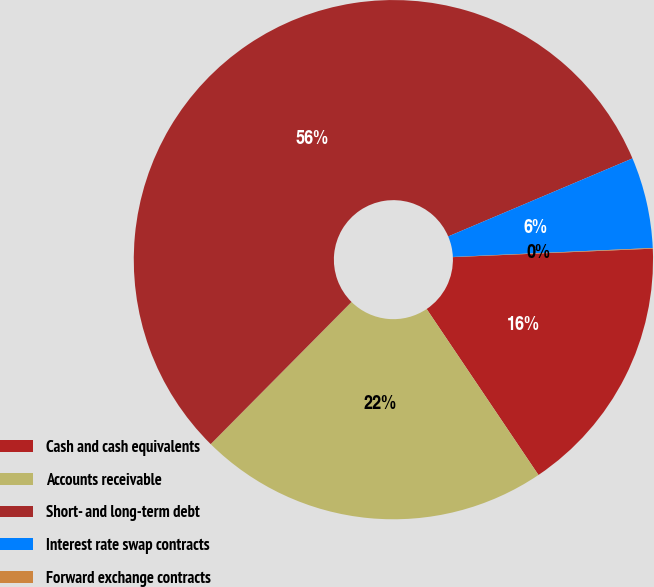Convert chart. <chart><loc_0><loc_0><loc_500><loc_500><pie_chart><fcel>Cash and cash equivalents<fcel>Accounts receivable<fcel>Short- and long-term debt<fcel>Interest rate swap contracts<fcel>Forward exchange contracts<nl><fcel>16.24%<fcel>21.86%<fcel>56.2%<fcel>5.66%<fcel>0.04%<nl></chart> 